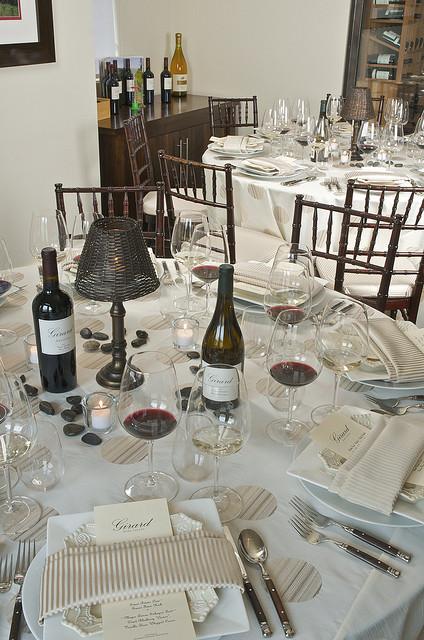Are any candles lit?
Quick response, please. Yes. What color is the wine?
Short answer required. Red. How many forks are at each place setting?
Answer briefly. 2. 